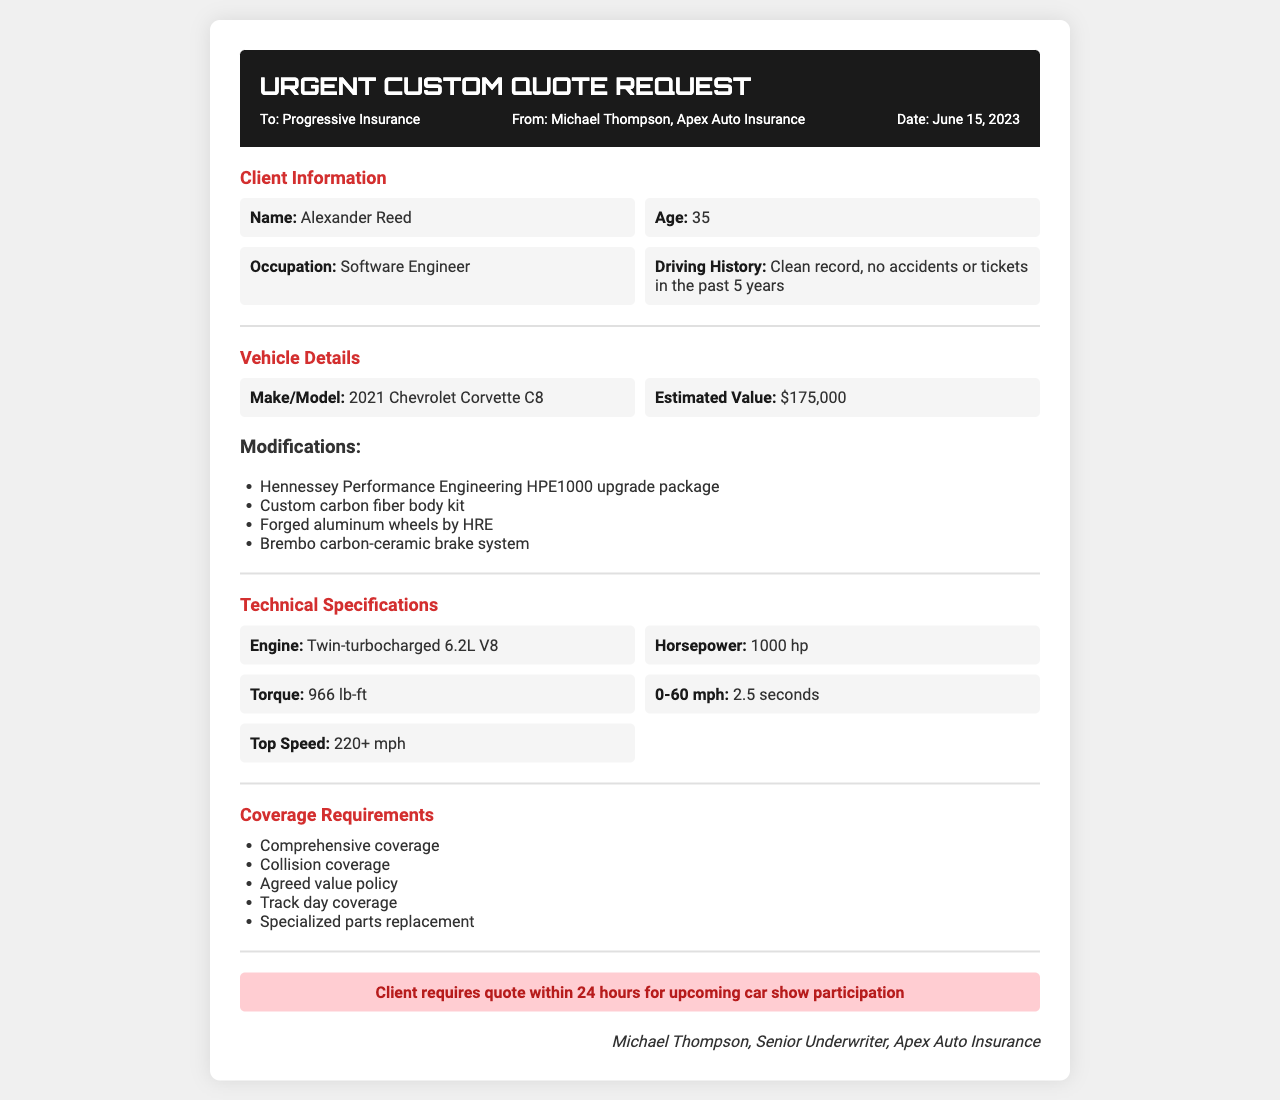What is the client's name? The client's name is listed in the document under Client Information as Alexander Reed.
Answer: Alexander Reed What is the estimated value of the vehicle? The estimated value is provided in the Vehicle Details section as $175,000.
Answer: $175,000 How much horsepower does the modified car have? The horsepower is specified in the Technical Specifications section as 1000 hp.
Answer: 1000 hp What kind of brake system is mentioned? The brake system is described under Modifications as a Brembo carbon-ceramic brake system.
Answer: Brembo carbon-ceramic brake system What type of insurance coverage is required? The document lists the required coverage in the Coverage Requirements section, including comprehensive coverage.
Answer: Comprehensive coverage How quickly does the client need the quote? The urgency note states that the client requires the quote within 24 hours.
Answer: 24 hours What is the make and model of the vehicle? The vehicle's make and model are given in the Vehicle Details section as 2021 Chevrolet Corvette C8.
Answer: 2021 Chevrolet Corvette C8 What is the name of the sender? The sender's name is listed in the header of the document as Michael Thompson.
Answer: Michael Thompson How fast can the car go from 0 to 60 mph? The 0-60 mph time is specified in the Technical Specifications as 2.5 seconds.
Answer: 2.5 seconds 